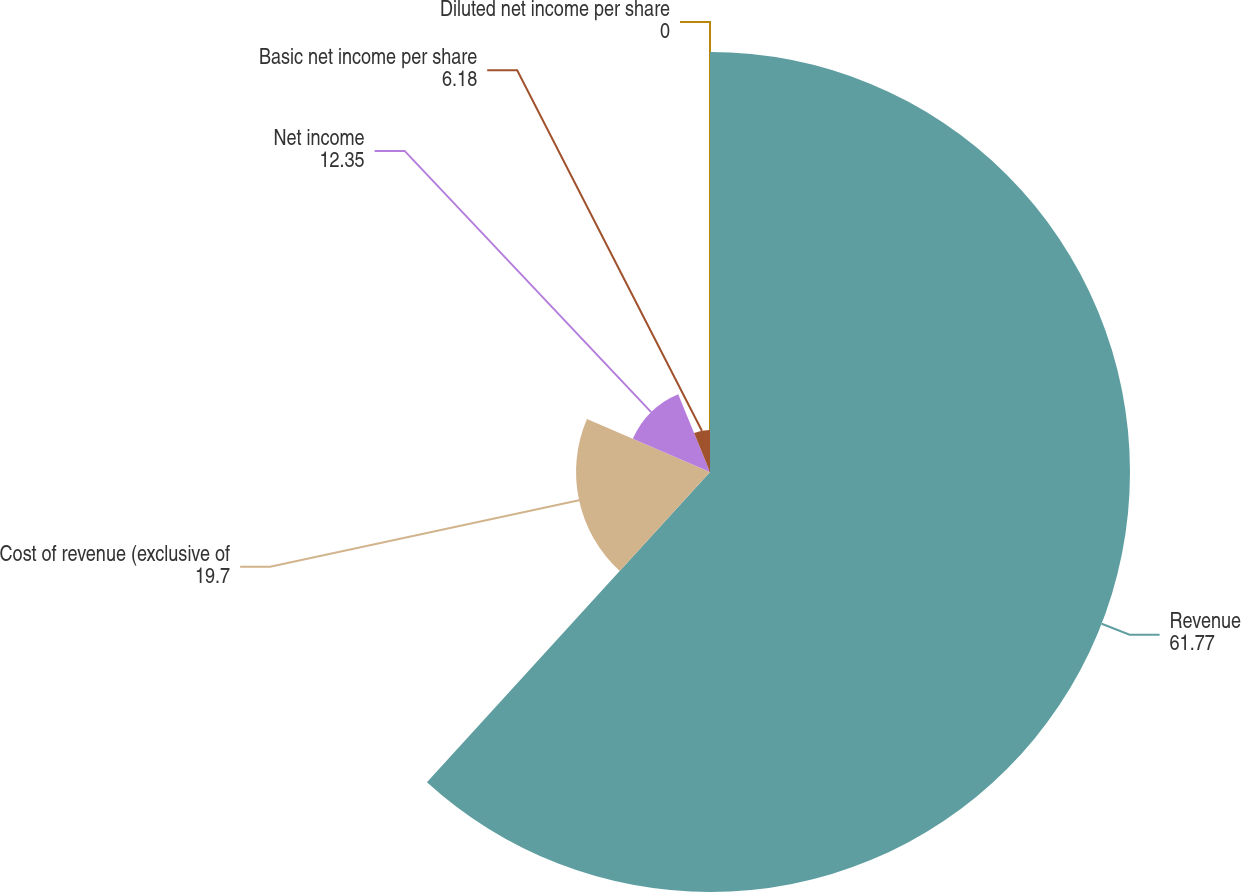Convert chart. <chart><loc_0><loc_0><loc_500><loc_500><pie_chart><fcel>Revenue<fcel>Cost of revenue (exclusive of<fcel>Net income<fcel>Basic net income per share<fcel>Diluted net income per share<nl><fcel>61.77%<fcel>19.7%<fcel>12.35%<fcel>6.18%<fcel>0.0%<nl></chart> 